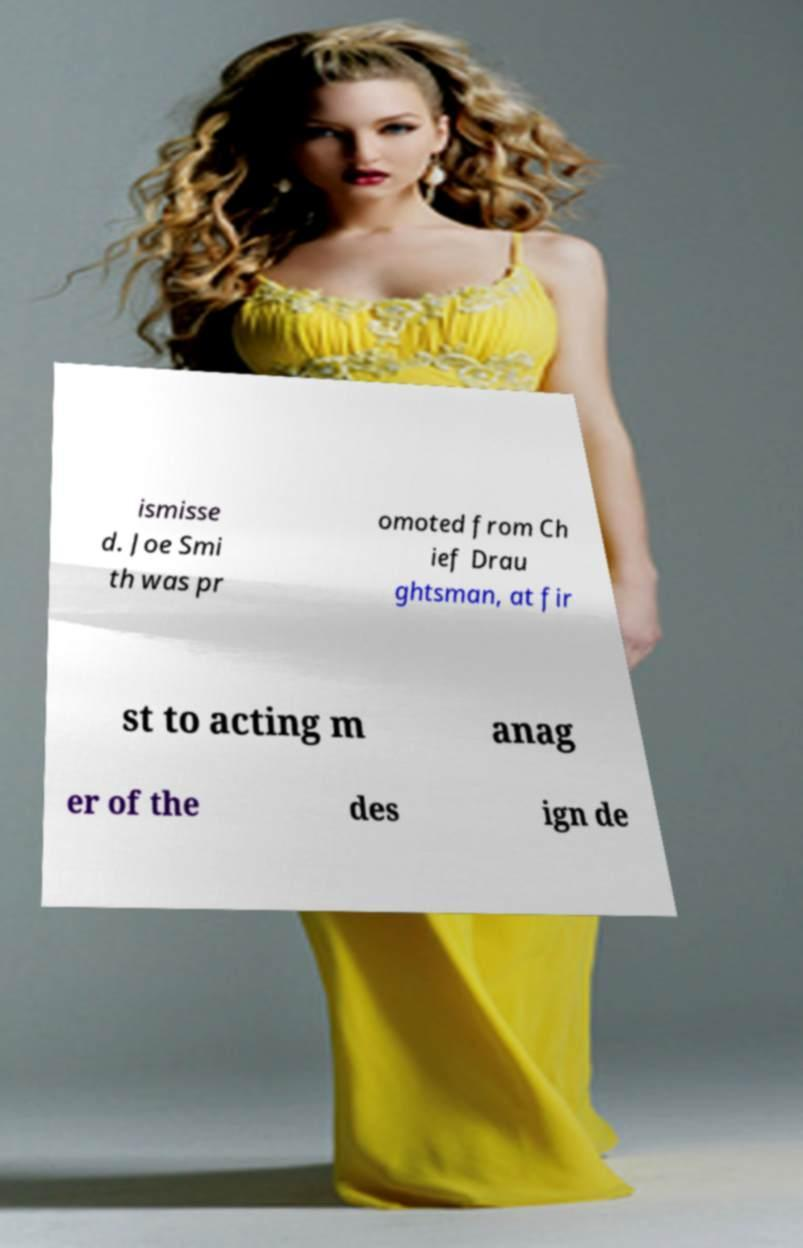What messages or text are displayed in this image? I need them in a readable, typed format. ismisse d. Joe Smi th was pr omoted from Ch ief Drau ghtsman, at fir st to acting m anag er of the des ign de 